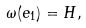Convert formula to latex. <formula><loc_0><loc_0><loc_500><loc_500>\omega ( e _ { 1 } ) = H ,</formula> 